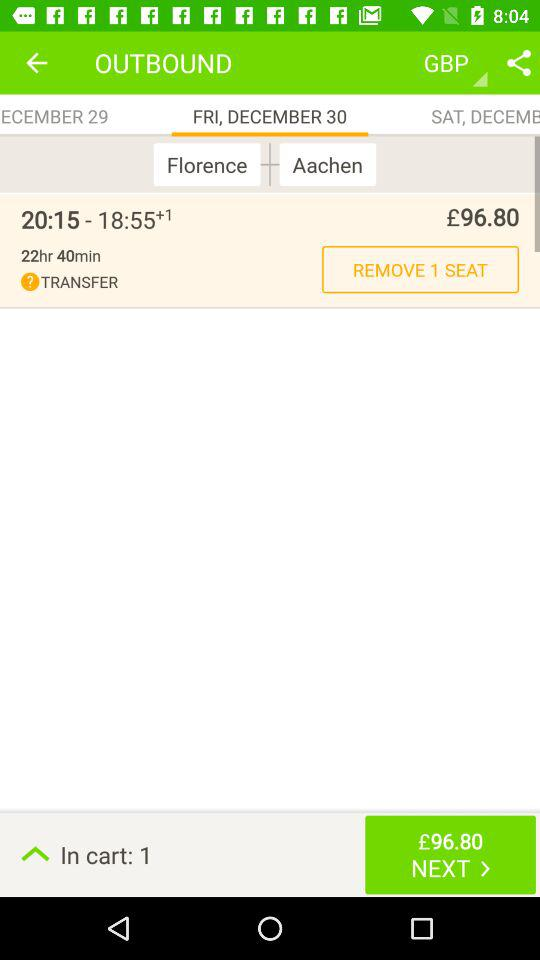What is the departure time of the flight? The departure time is 8:15 PM. 